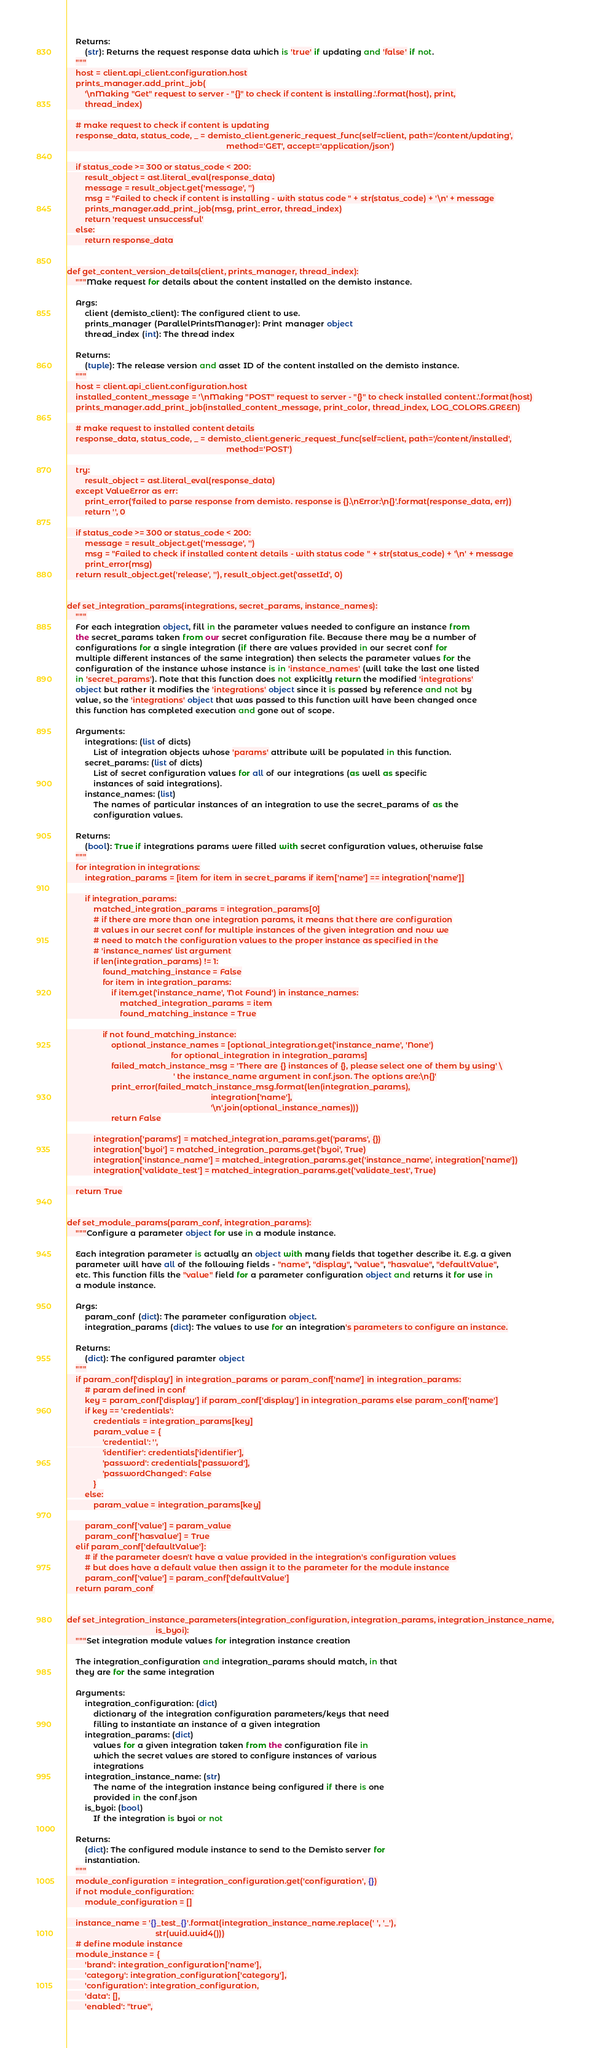Convert code to text. <code><loc_0><loc_0><loc_500><loc_500><_Python_>    Returns:
        (str): Returns the request response data which is 'true' if updating and 'false' if not.
    """
    host = client.api_client.configuration.host
    prints_manager.add_print_job(
        '\nMaking "Get" request to server - "{}" to check if content is installing.'.format(host), print,
        thread_index)

    # make request to check if content is updating
    response_data, status_code, _ = demisto_client.generic_request_func(self=client, path='/content/updating',
                                                                        method='GET', accept='application/json')

    if status_code >= 300 or status_code < 200:
        result_object = ast.literal_eval(response_data)
        message = result_object.get('message', '')
        msg = "Failed to check if content is installing - with status code " + str(status_code) + '\n' + message
        prints_manager.add_print_job(msg, print_error, thread_index)
        return 'request unsuccessful'
    else:
        return response_data


def get_content_version_details(client, prints_manager, thread_index):
    """Make request for details about the content installed on the demisto instance.

    Args:
        client (demisto_client): The configured client to use.
        prints_manager (ParallelPrintsManager): Print manager object
        thread_index (int): The thread index

    Returns:
        (tuple): The release version and asset ID of the content installed on the demisto instance.
    """
    host = client.api_client.configuration.host
    installed_content_message = '\nMaking "POST" request to server - "{}" to check installed content.'.format(host)
    prints_manager.add_print_job(installed_content_message, print_color, thread_index, LOG_COLORS.GREEN)

    # make request to installed content details
    response_data, status_code, _ = demisto_client.generic_request_func(self=client, path='/content/installed',
                                                                        method='POST')

    try:
        result_object = ast.literal_eval(response_data)
    except ValueError as err:
        print_error('failed to parse response from demisto. response is {}.\nError:\n{}'.format(response_data, err))
        return '', 0

    if status_code >= 300 or status_code < 200:
        message = result_object.get('message', '')
        msg = "Failed to check if installed content details - with status code " + str(status_code) + '\n' + message
        print_error(msg)
    return result_object.get('release', ''), result_object.get('assetId', 0)


def set_integration_params(integrations, secret_params, instance_names):
    """
    For each integration object, fill in the parameter values needed to configure an instance from
    the secret_params taken from our secret configuration file. Because there may be a number of
    configurations for a single integration (if there are values provided in our secret conf for
    multiple different instances of the same integration) then selects the parameter values for the
    configuration of the instance whose instance is in 'instance_names' (will take the last one listed
    in 'secret_params'). Note that this function does not explicitly return the modified 'integrations'
    object but rather it modifies the 'integrations' object since it is passed by reference and not by
    value, so the 'integrations' object that was passed to this function will have been changed once
    this function has completed execution and gone out of scope.

    Arguments:
        integrations: (list of dicts)
            List of integration objects whose 'params' attribute will be populated in this function.
        secret_params: (list of dicts)
            List of secret configuration values for all of our integrations (as well as specific
            instances of said integrations).
        instance_names: (list)
            The names of particular instances of an integration to use the secret_params of as the
            configuration values.

    Returns:
        (bool): True if integrations params were filled with secret configuration values, otherwise false
    """
    for integration in integrations:
        integration_params = [item for item in secret_params if item['name'] == integration['name']]

        if integration_params:
            matched_integration_params = integration_params[0]
            # if there are more than one integration params, it means that there are configuration
            # values in our secret conf for multiple instances of the given integration and now we
            # need to match the configuration values to the proper instance as specified in the
            # 'instance_names' list argument
            if len(integration_params) != 1:
                found_matching_instance = False
                for item in integration_params:
                    if item.get('instance_name', 'Not Found') in instance_names:
                        matched_integration_params = item
                        found_matching_instance = True

                if not found_matching_instance:
                    optional_instance_names = [optional_integration.get('instance_name', 'None')
                                               for optional_integration in integration_params]
                    failed_match_instance_msg = 'There are {} instances of {}, please select one of them by using' \
                                                ' the instance_name argument in conf.json. The options are:\n{}'
                    print_error(failed_match_instance_msg.format(len(integration_params),
                                                                 integration['name'],
                                                                 '\n'.join(optional_instance_names)))
                    return False

            integration['params'] = matched_integration_params.get('params', {})
            integration['byoi'] = matched_integration_params.get('byoi', True)
            integration['instance_name'] = matched_integration_params.get('instance_name', integration['name'])
            integration['validate_test'] = matched_integration_params.get('validate_test', True)

    return True


def set_module_params(param_conf, integration_params):
    """Configure a parameter object for use in a module instance.

    Each integration parameter is actually an object with many fields that together describe it. E.g. a given
    parameter will have all of the following fields - "name", "display", "value", "hasvalue", "defaultValue",
    etc. This function fills the "value" field for a parameter configuration object and returns it for use in
    a module instance.

    Args:
        param_conf (dict): The parameter configuration object.
        integration_params (dict): The values to use for an integration's parameters to configure an instance.

    Returns:
        (dict): The configured paramter object
    """
    if param_conf['display'] in integration_params or param_conf['name'] in integration_params:
        # param defined in conf
        key = param_conf['display'] if param_conf['display'] in integration_params else param_conf['name']
        if key == 'credentials':
            credentials = integration_params[key]
            param_value = {
                'credential': '',
                'identifier': credentials['identifier'],
                'password': credentials['password'],
                'passwordChanged': False
            }
        else:
            param_value = integration_params[key]

        param_conf['value'] = param_value
        param_conf['hasvalue'] = True
    elif param_conf['defaultValue']:
        # if the parameter doesn't have a value provided in the integration's configuration values
        # but does have a default value then assign it to the parameter for the module instance
        param_conf['value'] = param_conf['defaultValue']
    return param_conf


def set_integration_instance_parameters(integration_configuration, integration_params, integration_instance_name,
                                        is_byoi):
    """Set integration module values for integration instance creation

    The integration_configuration and integration_params should match, in that
    they are for the same integration

    Arguments:
        integration_configuration: (dict)
            dictionary of the integration configuration parameters/keys that need
            filling to instantiate an instance of a given integration
        integration_params: (dict)
            values for a given integration taken from the configuration file in
            which the secret values are stored to configure instances of various
            integrations
        integration_instance_name: (str)
            The name of the integration instance being configured if there is one
            provided in the conf.json
        is_byoi: (bool)
            If the integration is byoi or not

    Returns:
        (dict): The configured module instance to send to the Demisto server for
        instantiation.
    """
    module_configuration = integration_configuration.get('configuration', {})
    if not module_configuration:
        module_configuration = []

    instance_name = '{}_test_{}'.format(integration_instance_name.replace(' ', '_'),
                                        str(uuid.uuid4()))
    # define module instance
    module_instance = {
        'brand': integration_configuration['name'],
        'category': integration_configuration['category'],
        'configuration': integration_configuration,
        'data': [],
        'enabled': "true",</code> 